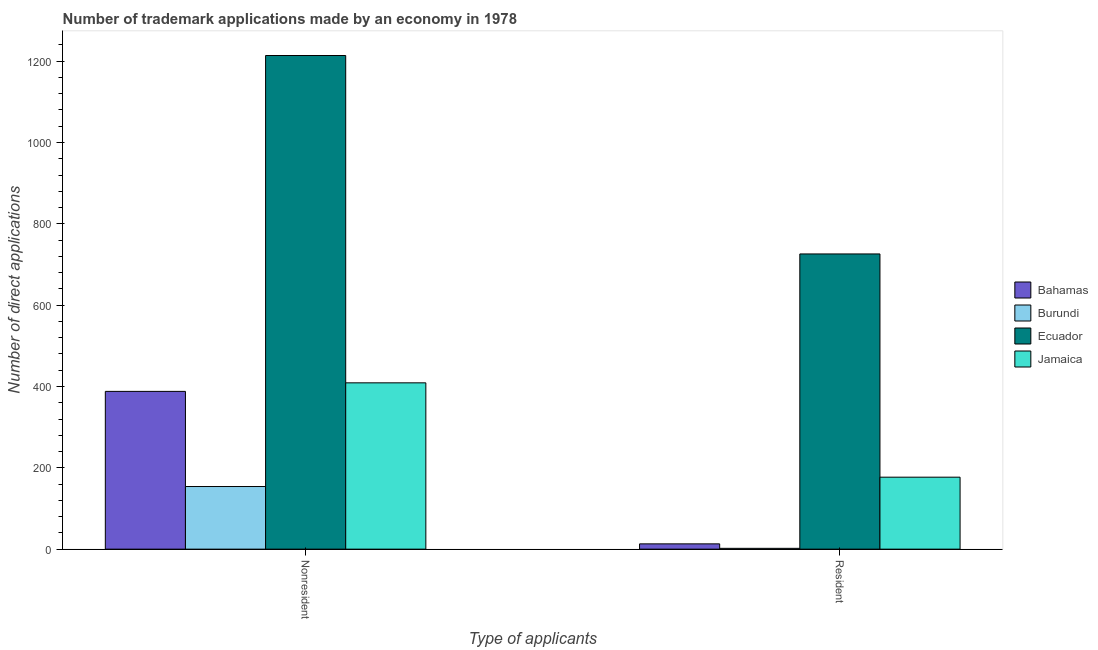How many groups of bars are there?
Give a very brief answer. 2. Are the number of bars per tick equal to the number of legend labels?
Your answer should be very brief. Yes. Are the number of bars on each tick of the X-axis equal?
Offer a terse response. Yes. How many bars are there on the 1st tick from the left?
Keep it short and to the point. 4. How many bars are there on the 1st tick from the right?
Ensure brevity in your answer.  4. What is the label of the 2nd group of bars from the left?
Offer a very short reply. Resident. What is the number of trademark applications made by non residents in Burundi?
Keep it short and to the point. 154. Across all countries, what is the maximum number of trademark applications made by non residents?
Provide a short and direct response. 1214. Across all countries, what is the minimum number of trademark applications made by non residents?
Your answer should be compact. 154. In which country was the number of trademark applications made by non residents maximum?
Provide a short and direct response. Ecuador. In which country was the number of trademark applications made by non residents minimum?
Give a very brief answer. Burundi. What is the total number of trademark applications made by residents in the graph?
Provide a short and direct response. 918. What is the difference between the number of trademark applications made by non residents in Bahamas and that in Jamaica?
Your answer should be very brief. -21. What is the difference between the number of trademark applications made by residents in Bahamas and the number of trademark applications made by non residents in Burundi?
Your answer should be very brief. -141. What is the average number of trademark applications made by residents per country?
Offer a very short reply. 229.5. What is the difference between the number of trademark applications made by non residents and number of trademark applications made by residents in Jamaica?
Provide a short and direct response. 232. What is the ratio of the number of trademark applications made by non residents in Burundi to that in Bahamas?
Your answer should be very brief. 0.4. Is the number of trademark applications made by residents in Ecuador less than that in Jamaica?
Give a very brief answer. No. In how many countries, is the number of trademark applications made by residents greater than the average number of trademark applications made by residents taken over all countries?
Ensure brevity in your answer.  1. What does the 1st bar from the left in Nonresident represents?
Offer a terse response. Bahamas. What does the 4th bar from the right in Nonresident represents?
Keep it short and to the point. Bahamas. How many bars are there?
Your answer should be very brief. 8. Are all the bars in the graph horizontal?
Give a very brief answer. No. How many countries are there in the graph?
Your answer should be compact. 4. What is the difference between two consecutive major ticks on the Y-axis?
Offer a terse response. 200. Does the graph contain any zero values?
Offer a terse response. No. Does the graph contain grids?
Ensure brevity in your answer.  No. Where does the legend appear in the graph?
Keep it short and to the point. Center right. How are the legend labels stacked?
Provide a succinct answer. Vertical. What is the title of the graph?
Ensure brevity in your answer.  Number of trademark applications made by an economy in 1978. What is the label or title of the X-axis?
Provide a short and direct response. Type of applicants. What is the label or title of the Y-axis?
Provide a succinct answer. Number of direct applications. What is the Number of direct applications in Bahamas in Nonresident?
Your answer should be compact. 388. What is the Number of direct applications in Burundi in Nonresident?
Ensure brevity in your answer.  154. What is the Number of direct applications in Ecuador in Nonresident?
Keep it short and to the point. 1214. What is the Number of direct applications in Jamaica in Nonresident?
Make the answer very short. 409. What is the Number of direct applications in Ecuador in Resident?
Your answer should be very brief. 726. What is the Number of direct applications of Jamaica in Resident?
Provide a short and direct response. 177. Across all Type of applicants, what is the maximum Number of direct applications in Bahamas?
Your response must be concise. 388. Across all Type of applicants, what is the maximum Number of direct applications in Burundi?
Keep it short and to the point. 154. Across all Type of applicants, what is the maximum Number of direct applications of Ecuador?
Keep it short and to the point. 1214. Across all Type of applicants, what is the maximum Number of direct applications in Jamaica?
Your response must be concise. 409. Across all Type of applicants, what is the minimum Number of direct applications in Bahamas?
Your response must be concise. 13. Across all Type of applicants, what is the minimum Number of direct applications in Ecuador?
Your response must be concise. 726. Across all Type of applicants, what is the minimum Number of direct applications in Jamaica?
Keep it short and to the point. 177. What is the total Number of direct applications of Bahamas in the graph?
Give a very brief answer. 401. What is the total Number of direct applications of Burundi in the graph?
Your response must be concise. 156. What is the total Number of direct applications in Ecuador in the graph?
Your answer should be very brief. 1940. What is the total Number of direct applications of Jamaica in the graph?
Your answer should be very brief. 586. What is the difference between the Number of direct applications in Bahamas in Nonresident and that in Resident?
Give a very brief answer. 375. What is the difference between the Number of direct applications in Burundi in Nonresident and that in Resident?
Provide a short and direct response. 152. What is the difference between the Number of direct applications in Ecuador in Nonresident and that in Resident?
Provide a short and direct response. 488. What is the difference between the Number of direct applications of Jamaica in Nonresident and that in Resident?
Offer a very short reply. 232. What is the difference between the Number of direct applications in Bahamas in Nonresident and the Number of direct applications in Burundi in Resident?
Ensure brevity in your answer.  386. What is the difference between the Number of direct applications in Bahamas in Nonresident and the Number of direct applications in Ecuador in Resident?
Keep it short and to the point. -338. What is the difference between the Number of direct applications of Bahamas in Nonresident and the Number of direct applications of Jamaica in Resident?
Your answer should be very brief. 211. What is the difference between the Number of direct applications of Burundi in Nonresident and the Number of direct applications of Ecuador in Resident?
Offer a very short reply. -572. What is the difference between the Number of direct applications in Ecuador in Nonresident and the Number of direct applications in Jamaica in Resident?
Provide a succinct answer. 1037. What is the average Number of direct applications in Bahamas per Type of applicants?
Give a very brief answer. 200.5. What is the average Number of direct applications of Burundi per Type of applicants?
Offer a terse response. 78. What is the average Number of direct applications of Ecuador per Type of applicants?
Your answer should be compact. 970. What is the average Number of direct applications of Jamaica per Type of applicants?
Make the answer very short. 293. What is the difference between the Number of direct applications of Bahamas and Number of direct applications of Burundi in Nonresident?
Provide a short and direct response. 234. What is the difference between the Number of direct applications of Bahamas and Number of direct applications of Ecuador in Nonresident?
Your answer should be very brief. -826. What is the difference between the Number of direct applications of Bahamas and Number of direct applications of Jamaica in Nonresident?
Your response must be concise. -21. What is the difference between the Number of direct applications of Burundi and Number of direct applications of Ecuador in Nonresident?
Give a very brief answer. -1060. What is the difference between the Number of direct applications of Burundi and Number of direct applications of Jamaica in Nonresident?
Provide a short and direct response. -255. What is the difference between the Number of direct applications in Ecuador and Number of direct applications in Jamaica in Nonresident?
Make the answer very short. 805. What is the difference between the Number of direct applications of Bahamas and Number of direct applications of Burundi in Resident?
Offer a terse response. 11. What is the difference between the Number of direct applications of Bahamas and Number of direct applications of Ecuador in Resident?
Your answer should be very brief. -713. What is the difference between the Number of direct applications in Bahamas and Number of direct applications in Jamaica in Resident?
Make the answer very short. -164. What is the difference between the Number of direct applications of Burundi and Number of direct applications of Ecuador in Resident?
Make the answer very short. -724. What is the difference between the Number of direct applications in Burundi and Number of direct applications in Jamaica in Resident?
Your response must be concise. -175. What is the difference between the Number of direct applications of Ecuador and Number of direct applications of Jamaica in Resident?
Your response must be concise. 549. What is the ratio of the Number of direct applications in Bahamas in Nonresident to that in Resident?
Provide a short and direct response. 29.85. What is the ratio of the Number of direct applications in Ecuador in Nonresident to that in Resident?
Provide a succinct answer. 1.67. What is the ratio of the Number of direct applications of Jamaica in Nonresident to that in Resident?
Make the answer very short. 2.31. What is the difference between the highest and the second highest Number of direct applications of Bahamas?
Your answer should be very brief. 375. What is the difference between the highest and the second highest Number of direct applications in Burundi?
Ensure brevity in your answer.  152. What is the difference between the highest and the second highest Number of direct applications in Ecuador?
Your answer should be very brief. 488. What is the difference between the highest and the second highest Number of direct applications of Jamaica?
Your response must be concise. 232. What is the difference between the highest and the lowest Number of direct applications in Bahamas?
Provide a succinct answer. 375. What is the difference between the highest and the lowest Number of direct applications in Burundi?
Give a very brief answer. 152. What is the difference between the highest and the lowest Number of direct applications in Ecuador?
Give a very brief answer. 488. What is the difference between the highest and the lowest Number of direct applications of Jamaica?
Provide a short and direct response. 232. 